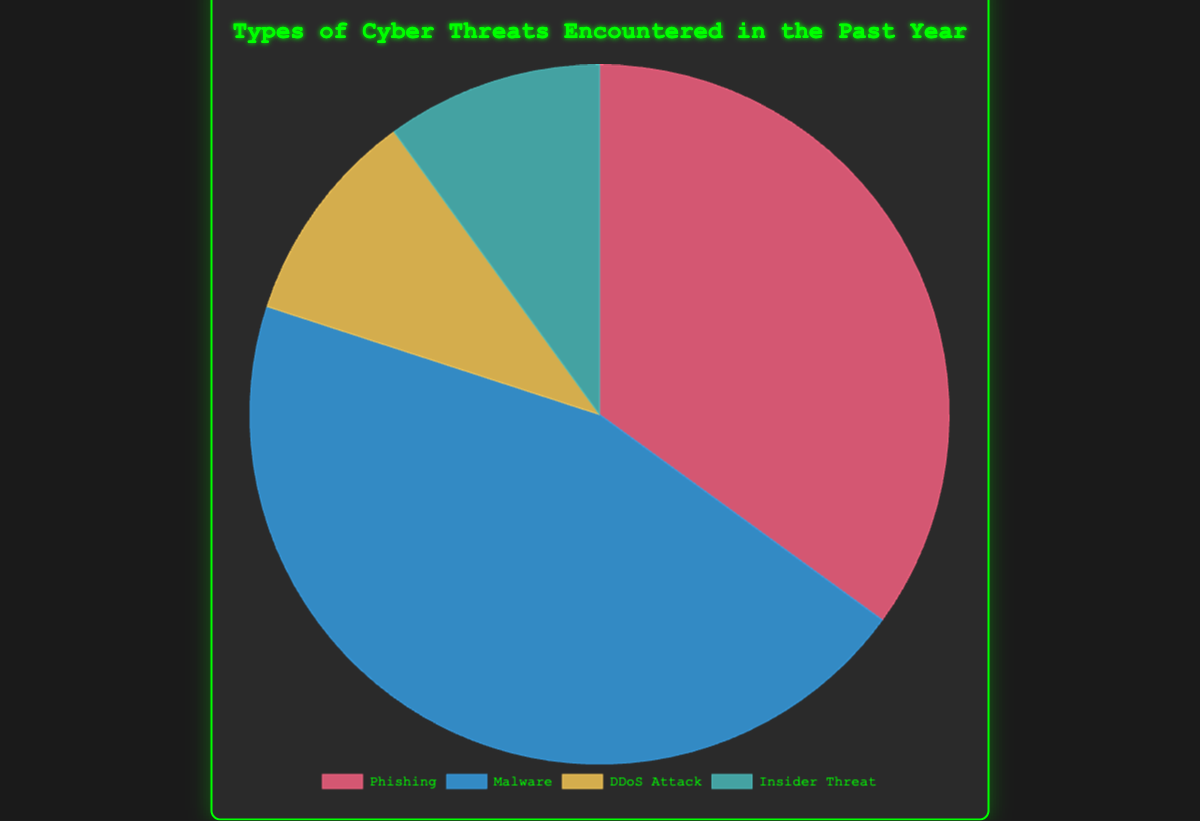What percentage of cyber threats were Phishing or Malware? To find the percentage of Phishing or Malware, sum their percentages: Phishing (35%) + Malware (45%) = 80%
Answer: 80% Which type of cyber threat is the least common? By looking at the data values, both DDoS Attack and Insider Threat have the lowest percentages (10%) among all types of cyber threats
Answer: DDoS Attack and Insider Threat How does the occurrence of Phishing compare to Insider Threat? The percentage of Phishing is 35%, while Insider Threat is 10%. Hence, Phishing is more common
Answer: Phishing is more common What is the combined share of DDoS Attack and Insider Threat in the total cyber threats? Sum the percentages of DDoS Attack (10%) and Insider Threat (10%): 10% + 10% = 20%
Answer: 20% What is the difference in percentage between Malware and Phishing? Subtract the percentage of Phishing (35%) from Malware (45%): 45% - 35% = 10%
Answer: 10% Which cyber threat has the highest incidence? The threat with the highest percentage value is Malware, with 45%
Answer: Malware What is the total percentage represented by the least common types of threats? Sum the percentages of the least common threats: DDoS Attack (10%) + Insider Threat (10%) = 20%
Answer: 20% Which segment in the pie chart is colored red? The 'Phishing' segment of the pie chart is colored red
Answer: Phishing By how much does the combined percentage of DDoS Attack and Insider Threat differ from Malware? Subtract the combined percentage of DDoS Attack and Insider Threat (20%) from Malware (45%): 45% - 20% = 25%
Answer: 25% If one were to encounter 100 cyber threats, how many would be Phishing? Calculate 35% of 100 threats: 100 * 0.35 = 35
Answer: 35 